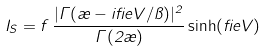Convert formula to latex. <formula><loc_0><loc_0><loc_500><loc_500>I _ { S } = f \, \frac { | \Gamma ( \rho - i \beta e V / \pi ) | ^ { 2 } } { \Gamma ( 2 \rho ) } \sinh ( \beta e V )</formula> 